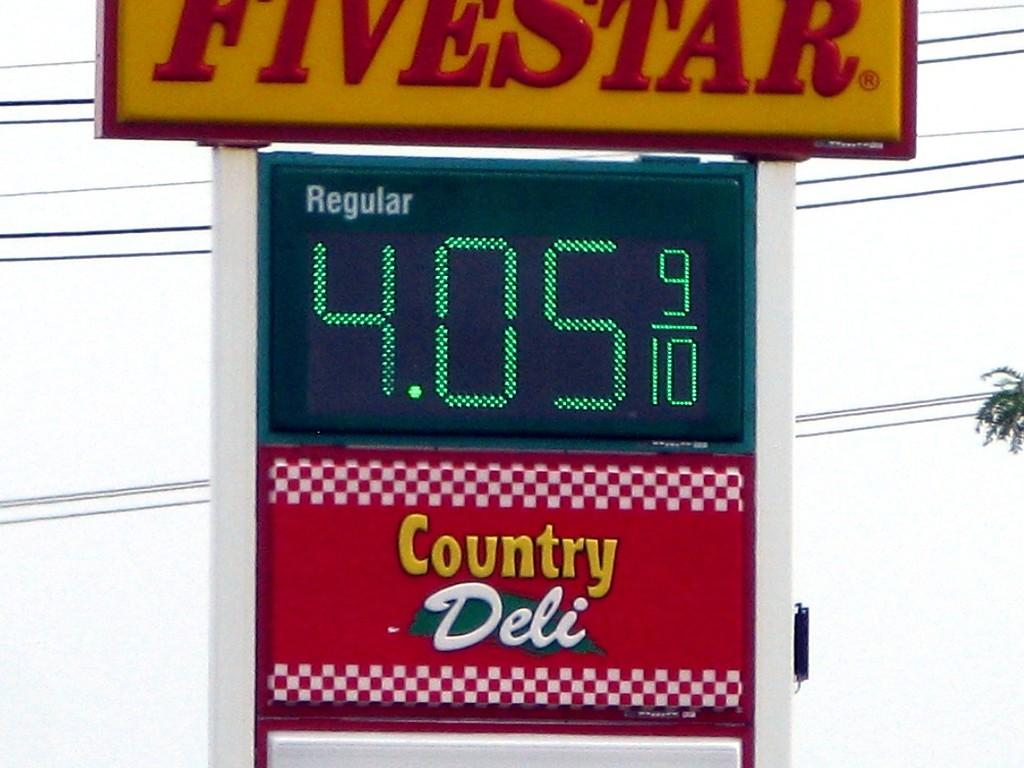<image>
Write a terse but informative summary of the picture. A gas station sign for the fivestar gas station showing a price of 4.05 for regular. 